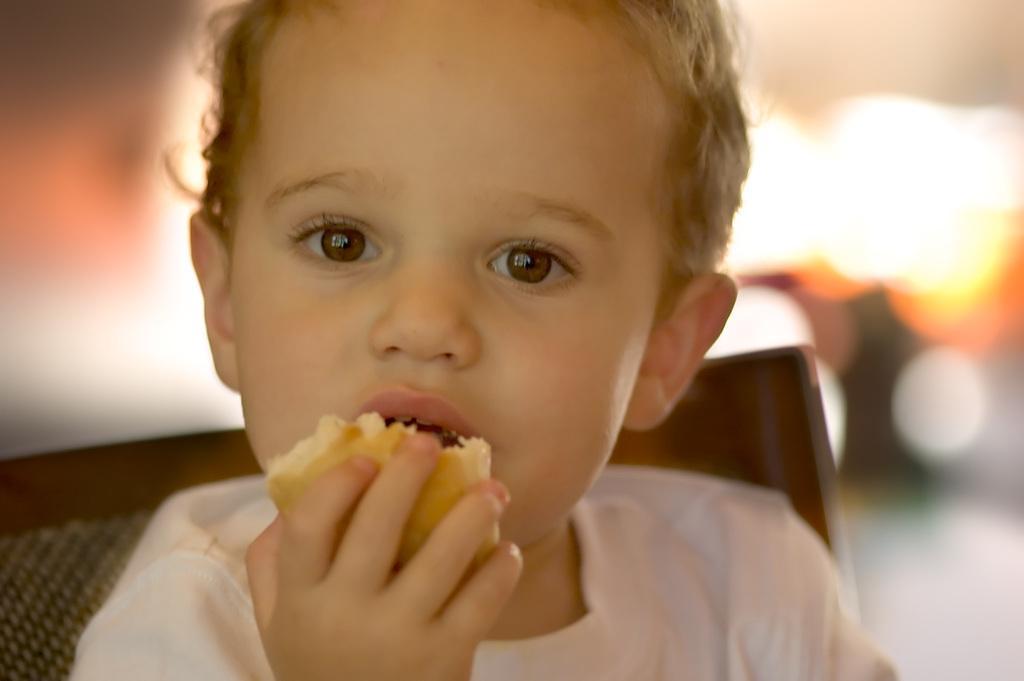Describe this image in one or two sentences. In this image, we can see a kid is holding some eatable thing and seeing. Here we can see a chair. Background there is a blur view. 